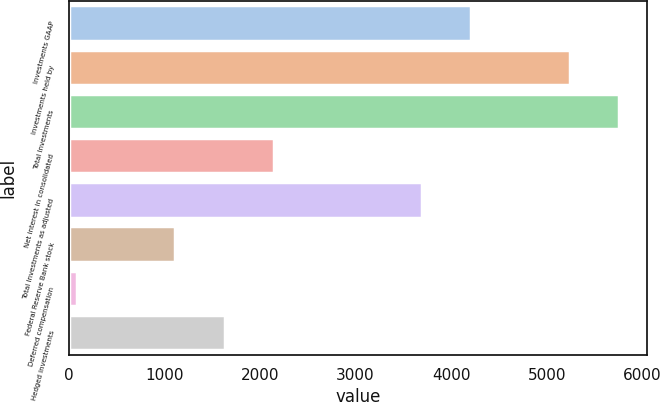Convert chart. <chart><loc_0><loc_0><loc_500><loc_500><bar_chart><fcel>Investments GAAP<fcel>Investments held by<fcel>Total Investments<fcel>Net interest in consolidated<fcel>Total Investments as adjusted<fcel>Federal Reserve Bank stock<fcel>Deferred compensation<fcel>Hedged investments<nl><fcel>4209.8<fcel>5241<fcel>5756.6<fcel>2147.4<fcel>3694.2<fcel>1116.2<fcel>85<fcel>1631.8<nl></chart> 